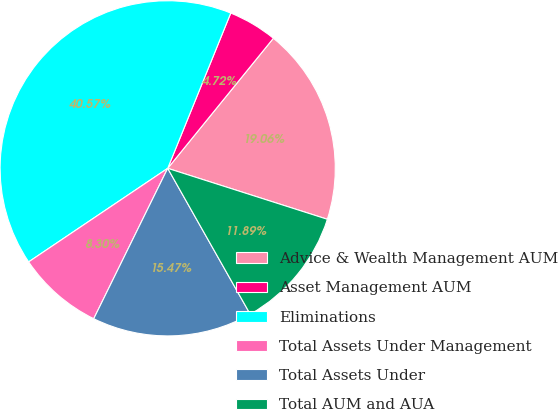Convert chart. <chart><loc_0><loc_0><loc_500><loc_500><pie_chart><fcel>Advice & Wealth Management AUM<fcel>Asset Management AUM<fcel>Eliminations<fcel>Total Assets Under Management<fcel>Total Assets Under<fcel>Total AUM and AUA<nl><fcel>19.06%<fcel>4.72%<fcel>40.57%<fcel>8.3%<fcel>15.47%<fcel>11.89%<nl></chart> 